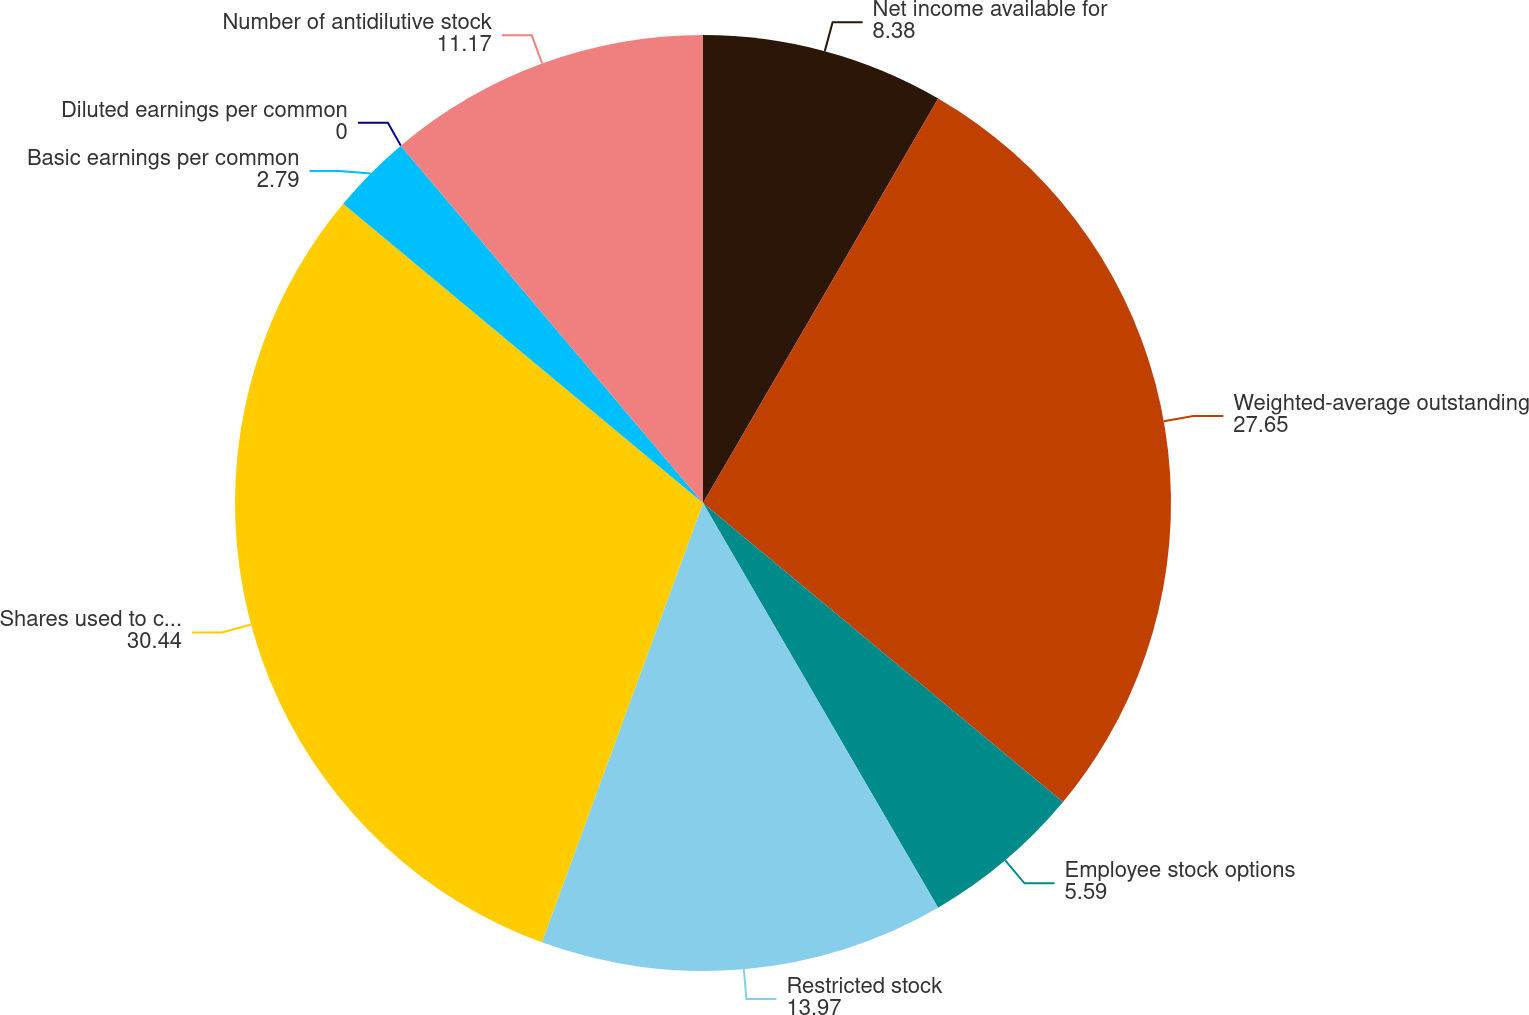<chart> <loc_0><loc_0><loc_500><loc_500><pie_chart><fcel>Net income available for<fcel>Weighted-average outstanding<fcel>Employee stock options<fcel>Restricted stock<fcel>Shares used to compute diluted<fcel>Basic earnings per common<fcel>Diluted earnings per common<fcel>Number of antidilutive stock<nl><fcel>8.38%<fcel>27.65%<fcel>5.59%<fcel>13.97%<fcel>30.44%<fcel>2.79%<fcel>0.0%<fcel>11.17%<nl></chart> 